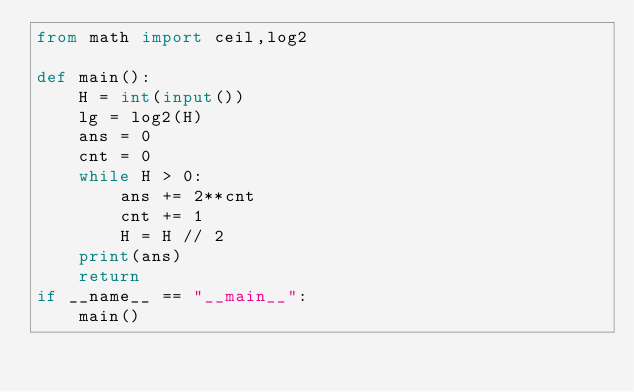Convert code to text. <code><loc_0><loc_0><loc_500><loc_500><_Python_>from math import ceil,log2

def main():
    H = int(input())
    lg = log2(H)
    ans = 0
    cnt = 0
    while H > 0:
        ans += 2**cnt
        cnt += 1
        H = H // 2
    print(ans)
    return
if __name__ == "__main__":
    main()</code> 